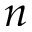Convert formula to latex. <formula><loc_0><loc_0><loc_500><loc_500>n</formula> 